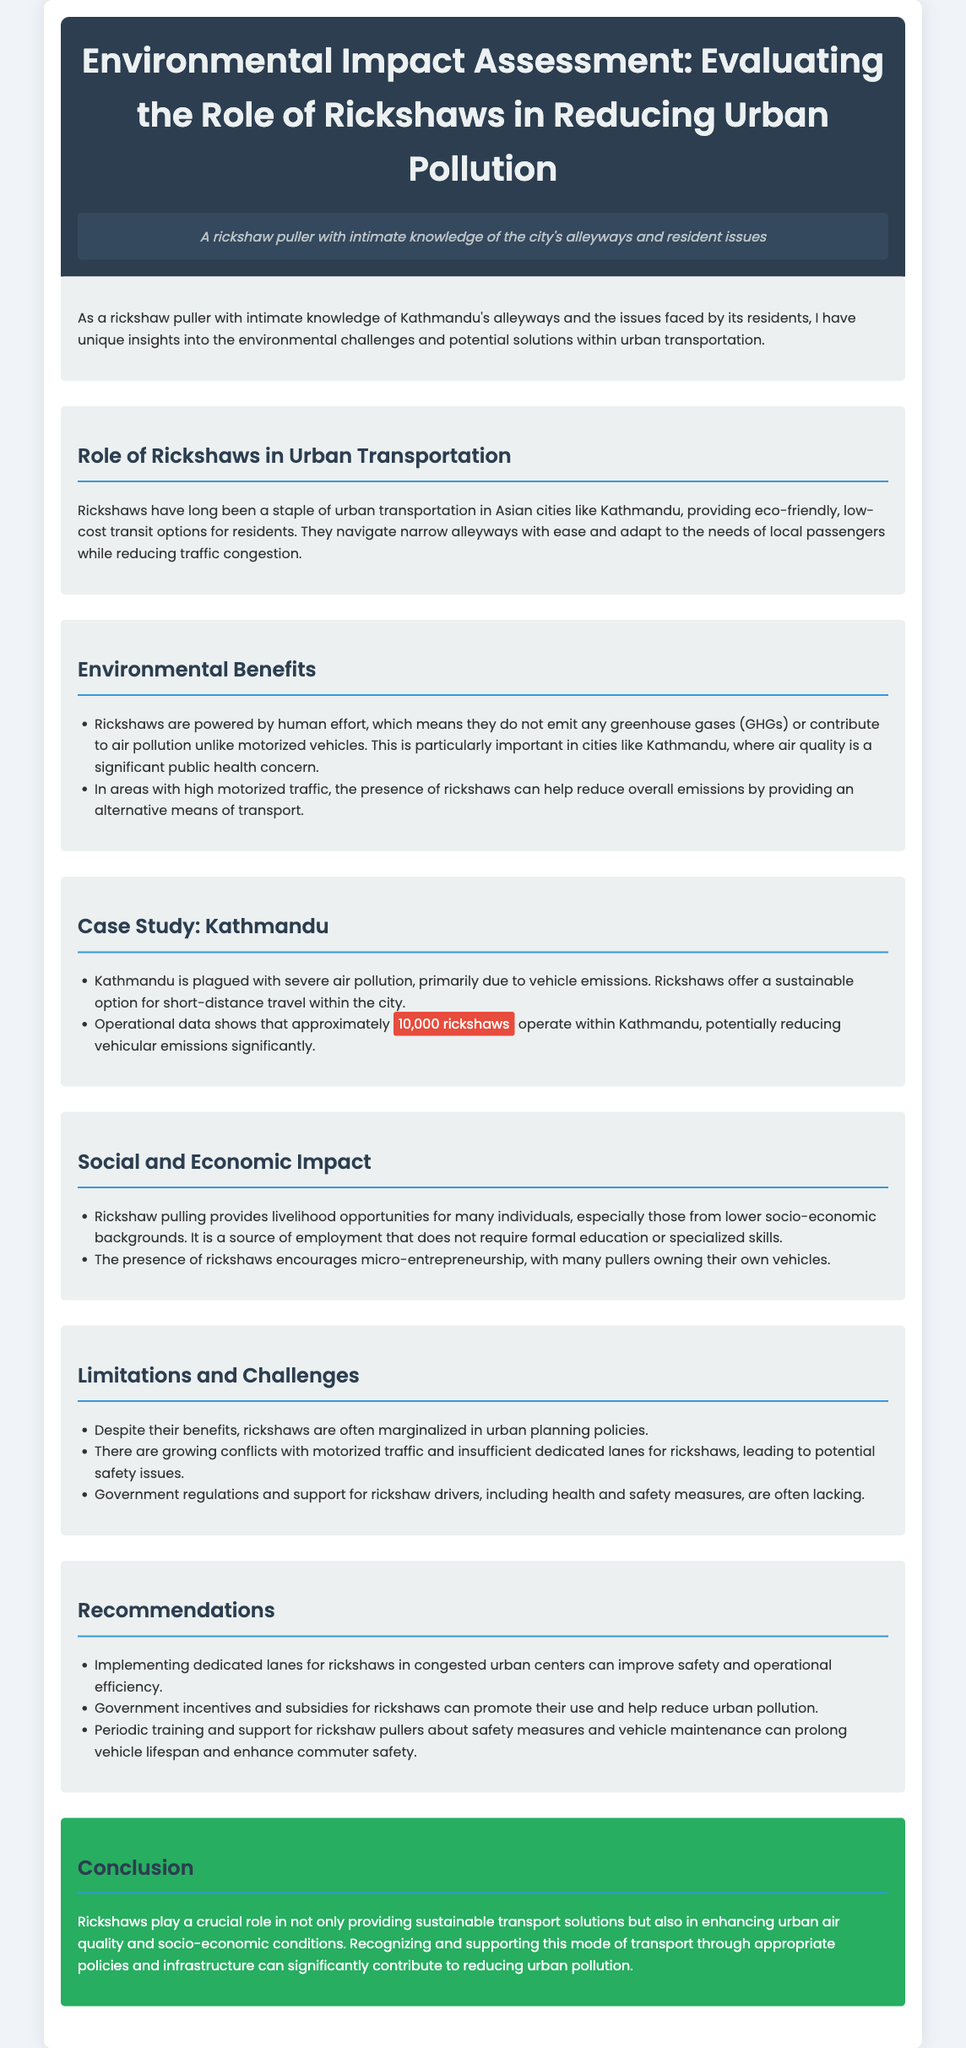What is the main focus of the document? The document primarily discusses the environmental impact of rickshaws in urban transportation.
Answer: Environmental impact of rickshaws How many rickshaws operate in Kathmandu? The document states that approximately 10,000 rickshaws operate within Kathmandu.
Answer: 10,000 What type of transportation do rickshaws provide? Rickshaws provide eco-friendly, low-cost transit options for residents.
Answer: Eco-friendly, low-cost transit What significant public health concern does Kathmandu face? The document mentions that air quality is a significant public health concern in Kathmandu.
Answer: Air quality What is a recommended measure to improve safety for rickshaw users? The document recommends implementing dedicated lanes for rickshaws to improve safety.
Answer: Dedicated lanes Which population benefits economically from rickshaw pulling? The document notes that individuals from lower socio-economic backgrounds benefit from rickshaw pulling.
Answer: Lower socio-economic backgrounds What is a major environmental benefit of rickshaws? Rickshaws do not emit any greenhouse gases or contribute to air pollution.
Answer: Do not emit greenhouse gases What challenge do rickshaws face in urban planning? Rickshaws are often marginalized in urban planning policies.
Answer: Marginalized in urban planning What is one of the social impacts of rickshaw operation? Rickshaw pulling provides livelihood opportunities for many individuals.
Answer: Livelihood opportunities 